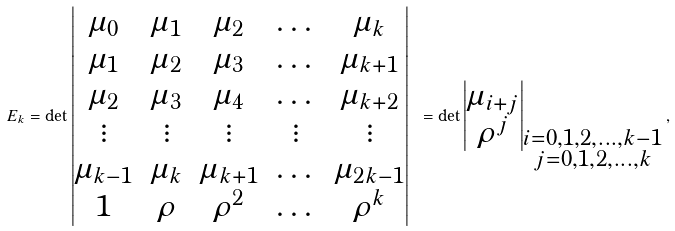<formula> <loc_0><loc_0><loc_500><loc_500>E _ { k } = \det \begin{vmatrix} \mu _ { 0 } & \mu _ { 1 } & \mu _ { 2 } & \dots & \mu _ { k } \\ \mu _ { 1 } & \mu _ { 2 } & \mu _ { 3 } & \dots & \mu _ { k + 1 } \\ \mu _ { 2 } & \mu _ { 3 } & \mu _ { 4 } & \dots & \mu _ { k + 2 } \\ \vdots & \vdots & \vdots & \vdots & \vdots \\ \mu _ { k - 1 } & \mu _ { k } & \mu _ { k + 1 } & \dots & \mu _ { 2 k - 1 } \\ 1 & \rho & \rho ^ { 2 } & \dots & \rho ^ { k } \end{vmatrix} \ = \det \begin{vmatrix} \mu _ { i + j } \\ \rho ^ { j } \end{vmatrix} _ { \substack { i = 0 , 1 , 2 , \dots , k - 1 \\ j = 0 , 1 , 2 , \dots , k } } ,</formula> 